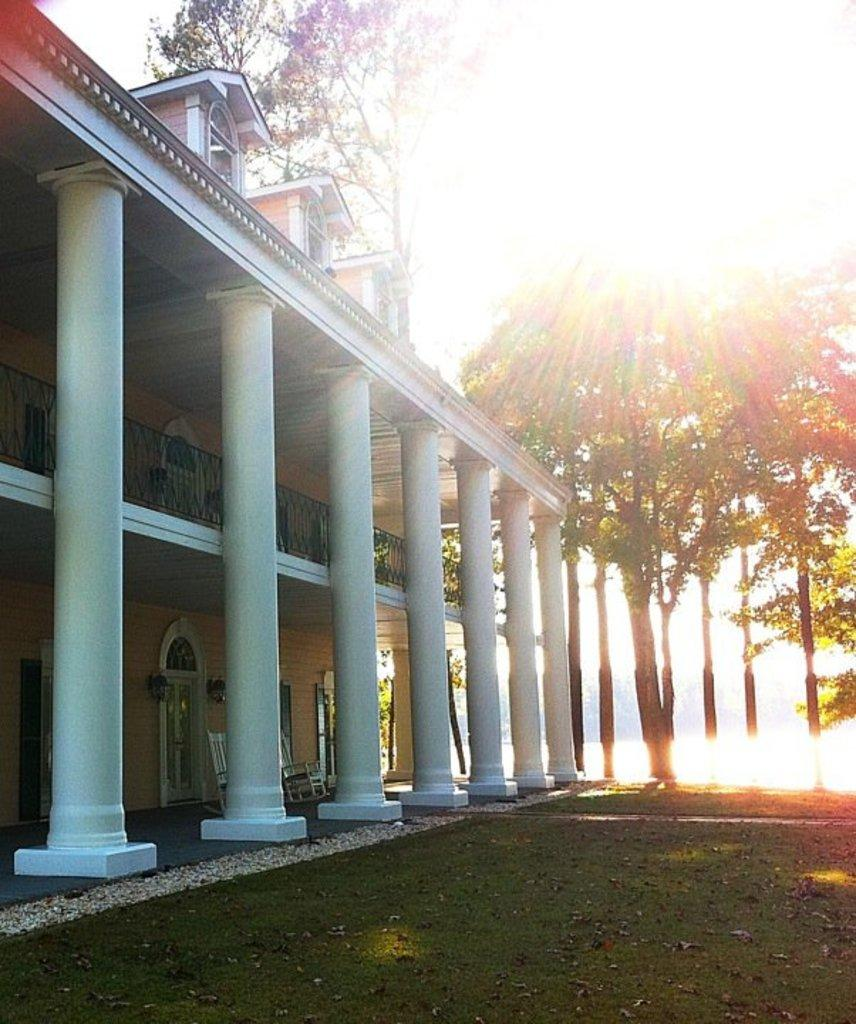What type of structure is present in the image? There is a building in the image. What natural elements can be seen in the image? There are trees and sunlight visible in the image. What architectural feature is present in the image? There are pillars in the image. What is the surface on which the building and trees are situated? There is a ground at the bottom of the image. How many people are seen jumping in the image? There are no people visible in the image, and therefore no jumping can be observed. What type of dock is present near the trees in the image? There is no dock present in the image; it features a building, trees, sunlight, pillars, and a ground. 